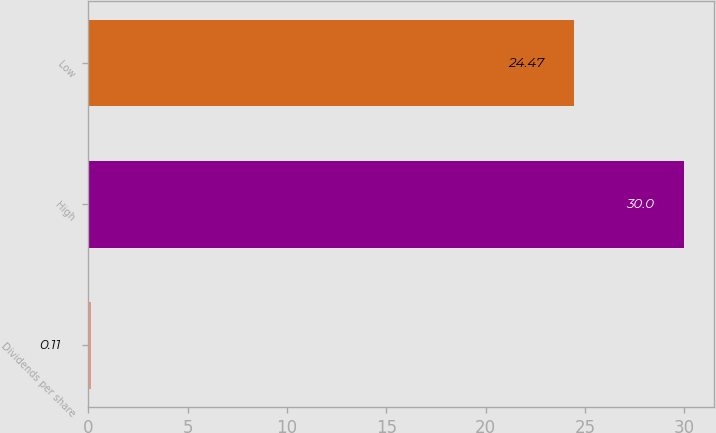Convert chart to OTSL. <chart><loc_0><loc_0><loc_500><loc_500><bar_chart><fcel>Dividends per share<fcel>High<fcel>Low<nl><fcel>0.11<fcel>30<fcel>24.47<nl></chart> 